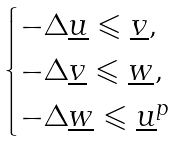<formula> <loc_0><loc_0><loc_500><loc_500>\begin{cases} - \Delta \underline { u } \leqslant \underline { v } , \\ - \Delta \underline { v } \leqslant \underline { w } , \\ - \Delta \underline { w } \leqslant \underline { u } ^ { p } \end{cases}</formula> 